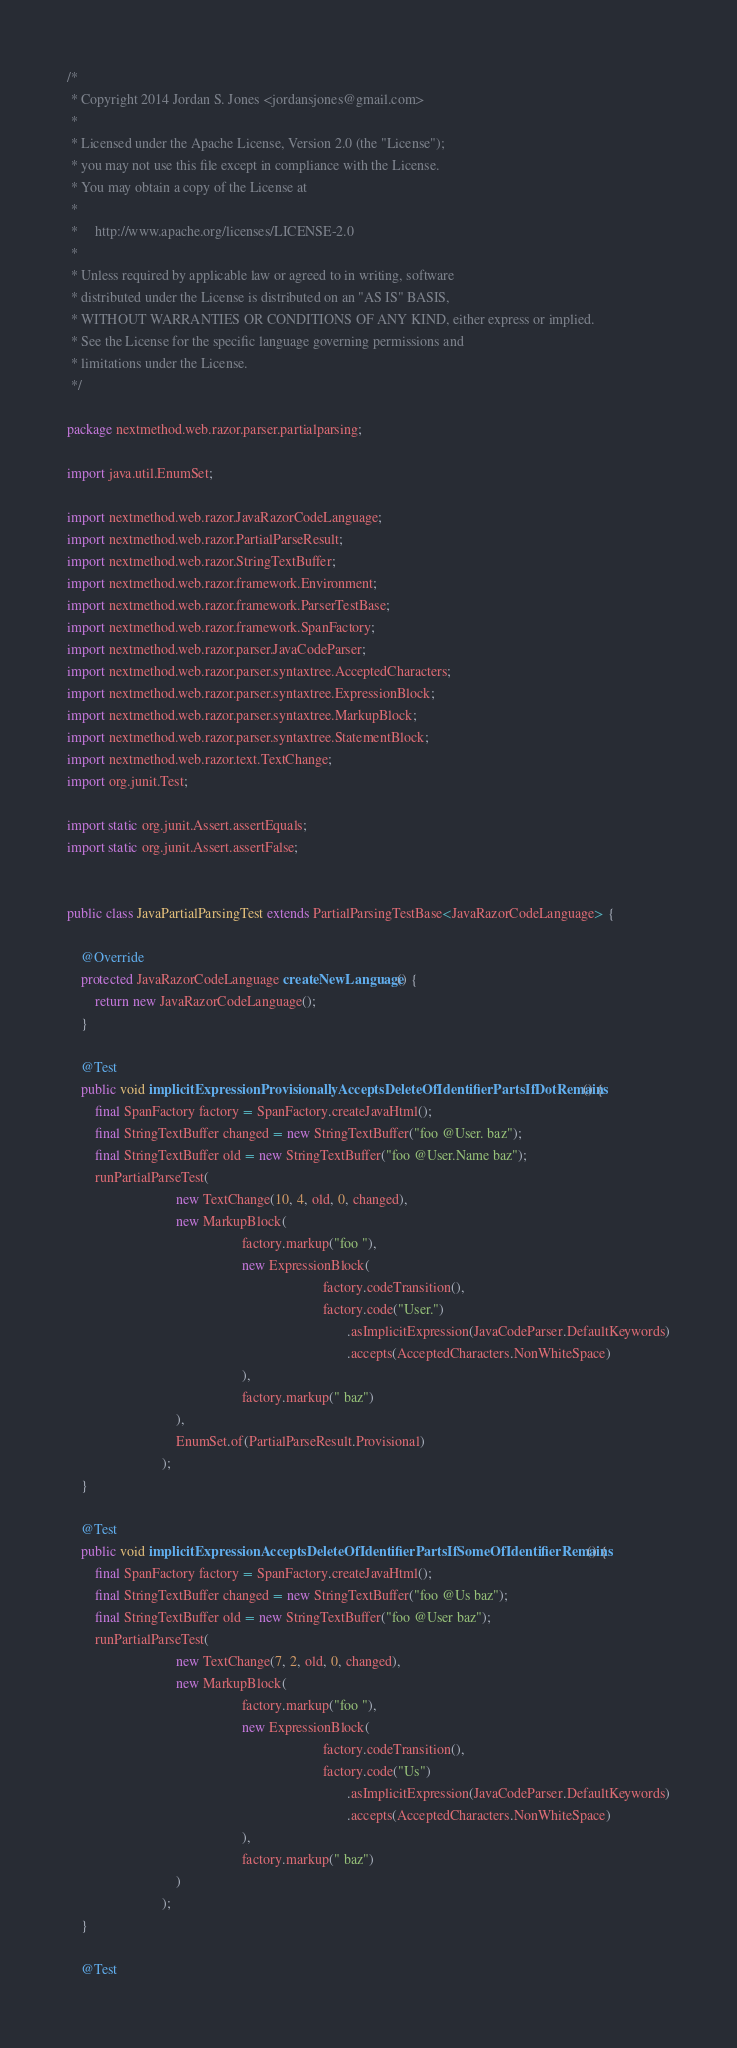Convert code to text. <code><loc_0><loc_0><loc_500><loc_500><_Java_>/*
 * Copyright 2014 Jordan S. Jones <jordansjones@gmail.com>
 *
 * Licensed under the Apache License, Version 2.0 (the "License");
 * you may not use this file except in compliance with the License.
 * You may obtain a copy of the License at
 *
 *     http://www.apache.org/licenses/LICENSE-2.0
 *
 * Unless required by applicable law or agreed to in writing, software
 * distributed under the License is distributed on an "AS IS" BASIS,
 * WITHOUT WARRANTIES OR CONDITIONS OF ANY KIND, either express or implied.
 * See the License for the specific language governing permissions and
 * limitations under the License.
 */

package nextmethod.web.razor.parser.partialparsing;

import java.util.EnumSet;

import nextmethod.web.razor.JavaRazorCodeLanguage;
import nextmethod.web.razor.PartialParseResult;
import nextmethod.web.razor.StringTextBuffer;
import nextmethod.web.razor.framework.Environment;
import nextmethod.web.razor.framework.ParserTestBase;
import nextmethod.web.razor.framework.SpanFactory;
import nextmethod.web.razor.parser.JavaCodeParser;
import nextmethod.web.razor.parser.syntaxtree.AcceptedCharacters;
import nextmethod.web.razor.parser.syntaxtree.ExpressionBlock;
import nextmethod.web.razor.parser.syntaxtree.MarkupBlock;
import nextmethod.web.razor.parser.syntaxtree.StatementBlock;
import nextmethod.web.razor.text.TextChange;
import org.junit.Test;

import static org.junit.Assert.assertEquals;
import static org.junit.Assert.assertFalse;


public class JavaPartialParsingTest extends PartialParsingTestBase<JavaRazorCodeLanguage> {

    @Override
    protected JavaRazorCodeLanguage createNewLanguage() {
        return new JavaRazorCodeLanguage();
    }

    @Test
    public void implicitExpressionProvisionallyAcceptsDeleteOfIdentifierPartsIfDotRemains() {
        final SpanFactory factory = SpanFactory.createJavaHtml();
        final StringTextBuffer changed = new StringTextBuffer("foo @User. baz");
        final StringTextBuffer old = new StringTextBuffer("foo @User.Name baz");
        runPartialParseTest(
                               new TextChange(10, 4, old, 0, changed),
                               new MarkupBlock(
                                                  factory.markup("foo "),
                                                  new ExpressionBlock(
                                                                         factory.codeTransition(),
                                                                         factory.code("User.")
                                                                                .asImplicitExpression(JavaCodeParser.DefaultKeywords)
                                                                                .accepts(AcceptedCharacters.NonWhiteSpace)
                                                  ),
                                                  factory.markup(" baz")
                               ),
                               EnumSet.of(PartialParseResult.Provisional)
                           );
    }

    @Test
    public void implicitExpressionAcceptsDeleteOfIdentifierPartsIfSomeOfIdentifierRemains() {
        final SpanFactory factory = SpanFactory.createJavaHtml();
        final StringTextBuffer changed = new StringTextBuffer("foo @Us baz");
        final StringTextBuffer old = new StringTextBuffer("foo @User baz");
        runPartialParseTest(
                               new TextChange(7, 2, old, 0, changed),
                               new MarkupBlock(
                                                  factory.markup("foo "),
                                                  new ExpressionBlock(
                                                                         factory.codeTransition(),
                                                                         factory.code("Us")
                                                                                .asImplicitExpression(JavaCodeParser.DefaultKeywords)
                                                                                .accepts(AcceptedCharacters.NonWhiteSpace)
                                                  ),
                                                  factory.markup(" baz")
                               )
                           );
    }

    @Test</code> 